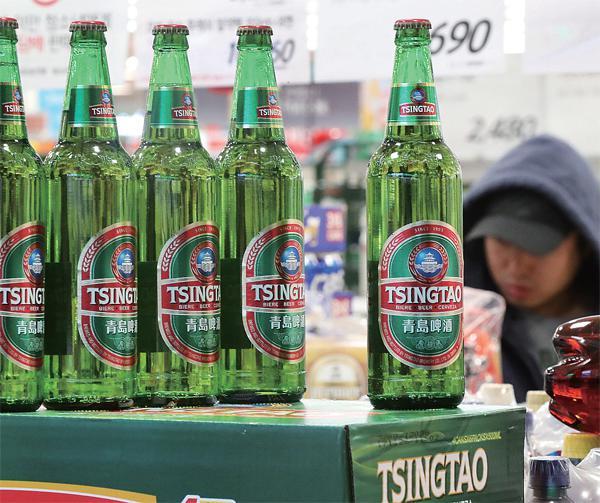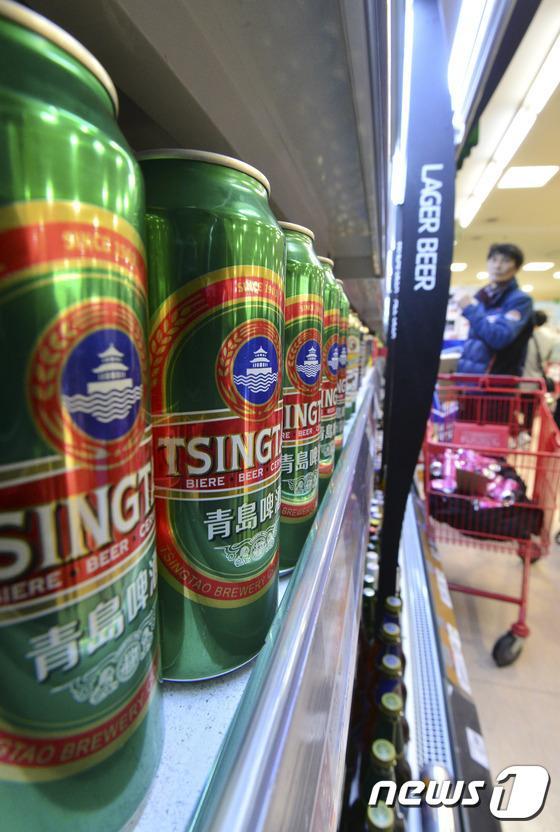The first image is the image on the left, the second image is the image on the right. Examine the images to the left and right. Is the description "There are exactly five bottles of beer in the left image." accurate? Answer yes or no. Yes. 